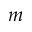<formula> <loc_0><loc_0><loc_500><loc_500>m</formula> 